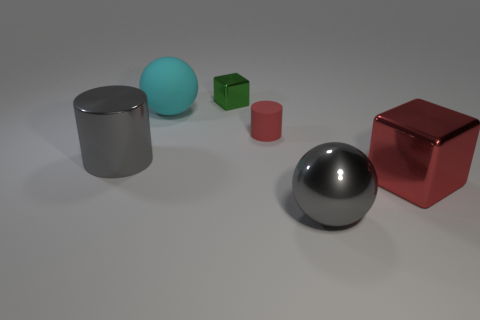There is a large cyan thing; how many small green things are right of it?
Your answer should be compact. 1. Does the cylinder that is in front of the tiny red rubber cylinder have the same color as the large metal sphere?
Keep it short and to the point. Yes. How many gray objects are blocks or cylinders?
Your answer should be very brief. 1. There is a sphere behind the metal cube that is to the right of the small cube; what color is it?
Make the answer very short. Cyan. What material is the cylinder that is the same color as the big metal block?
Your response must be concise. Rubber. What color is the sphere behind the small red matte cylinder?
Your response must be concise. Cyan. There is a cylinder to the right of the green metal cube; is it the same size as the tiny green metallic block?
Your answer should be very brief. Yes. There is a cube that is the same color as the small rubber thing; what is its size?
Offer a terse response. Large. Is there a block that has the same size as the gray ball?
Your answer should be very brief. Yes. Does the matte thing that is in front of the large cyan sphere have the same color as the block that is in front of the gray cylinder?
Ensure brevity in your answer.  Yes. 